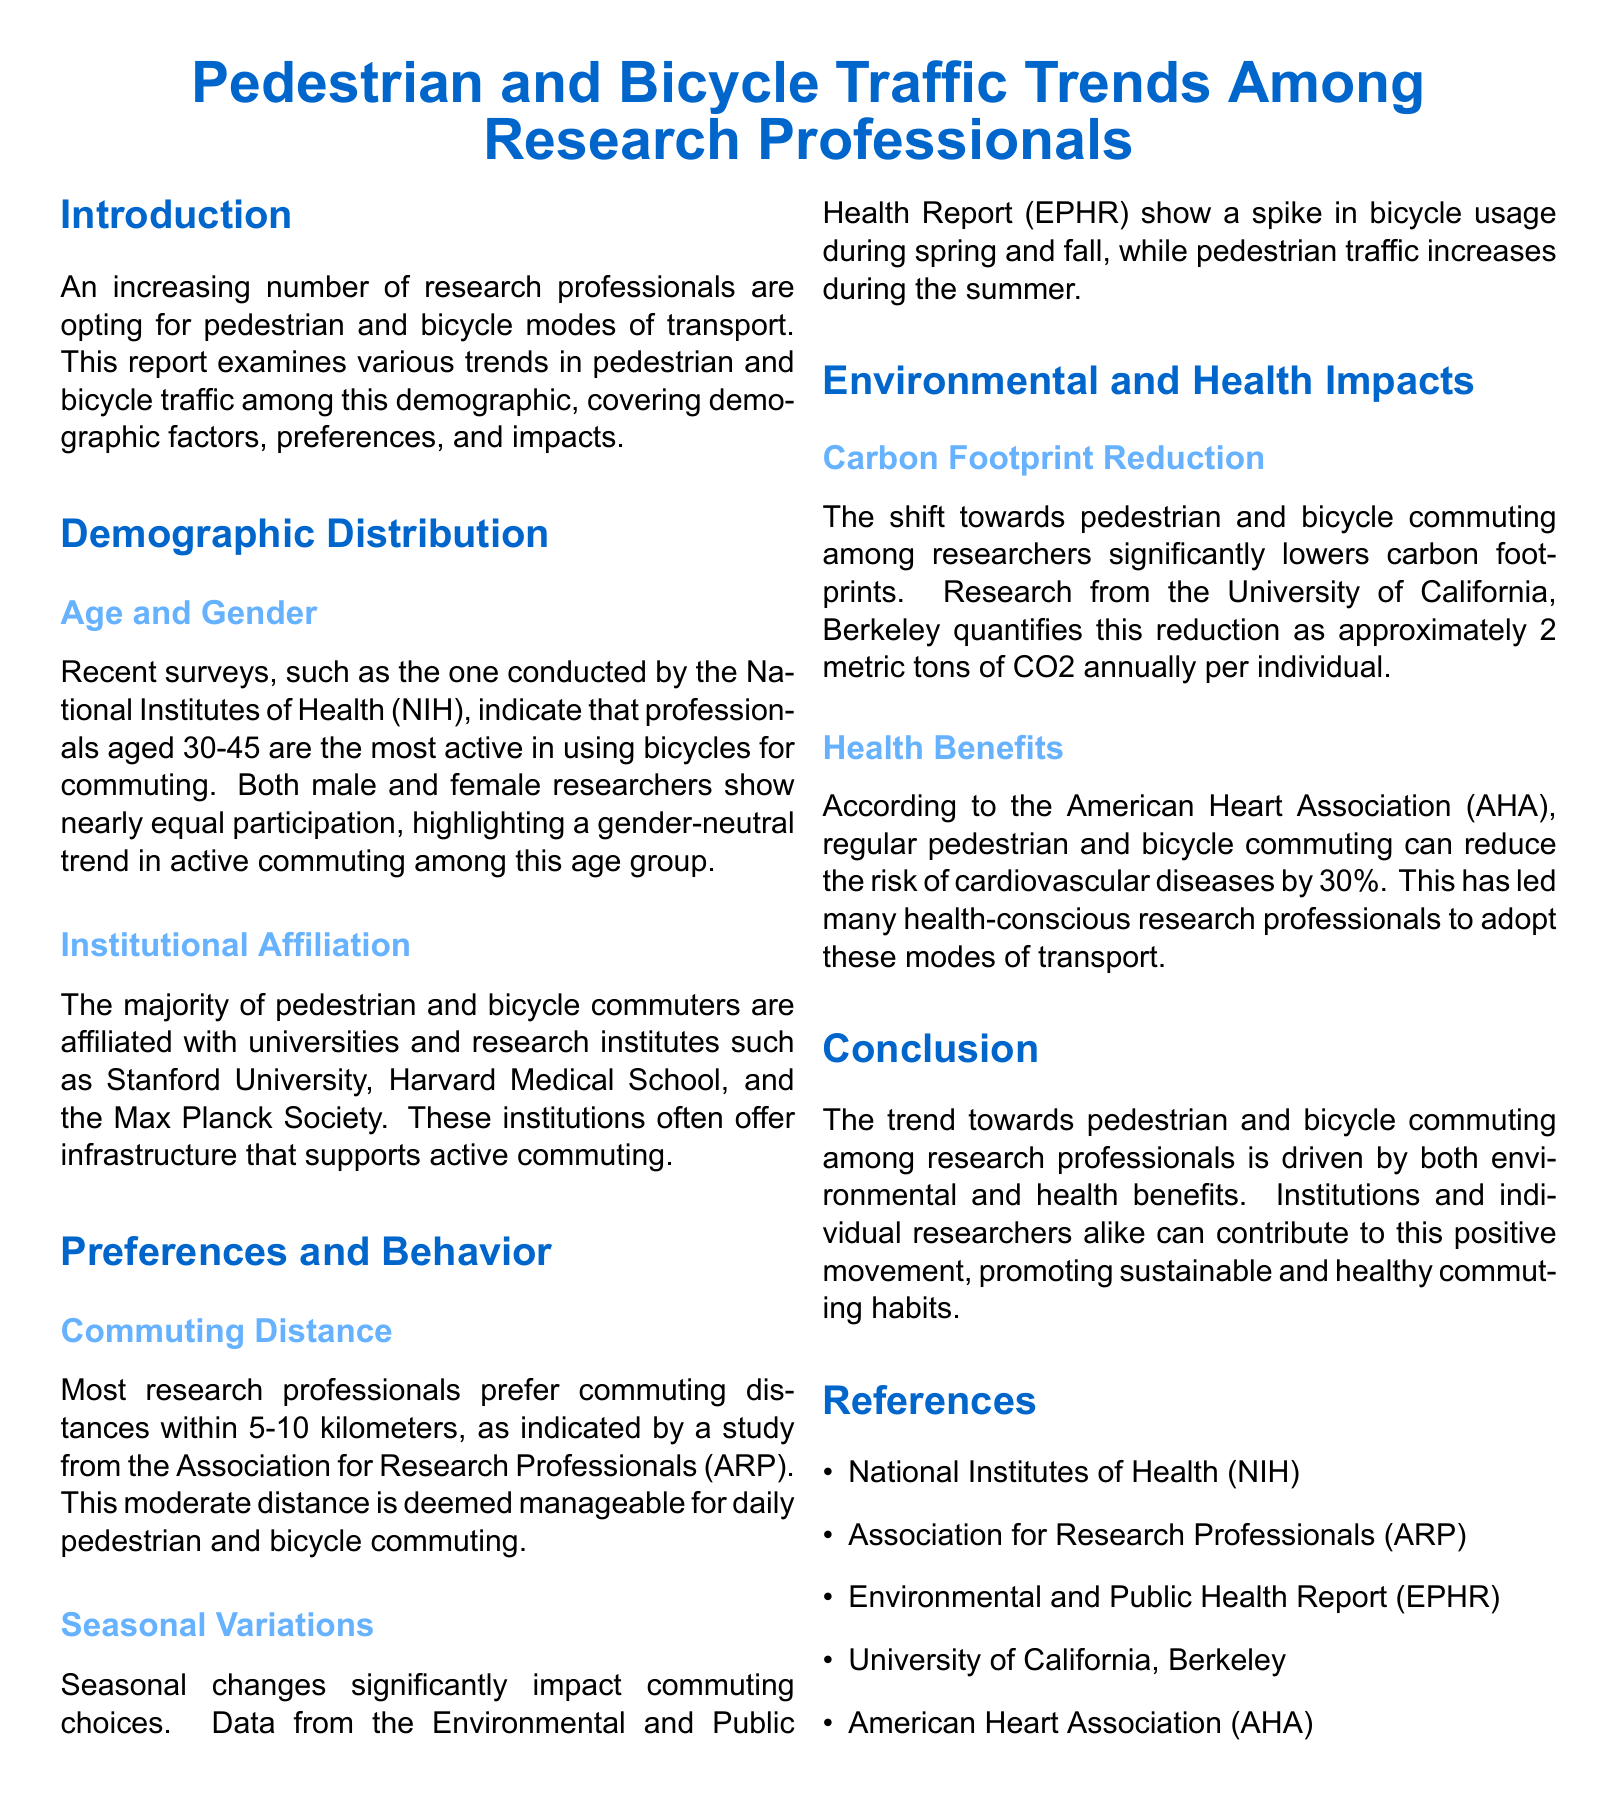What age group is most active in bicycle commuting? The document states that professionals aged 30-45 are the most active in using bicycles for commuting.
Answer: 30-45 Which institutions show the highest percentage of pedestrian and bicycle commuters? The report mentions universities and research institutes like Stanford University, Harvard Medical School, and the Max Planck Society.
Answer: Stanford University, Harvard Medical School, Max Planck Society What is the preferred commuting distance for most research professionals? According to the document, most research professionals prefer commuting distances within 5-10 kilometers.
Answer: 5-10 kilometers During which seasons does bicycle usage spike? The document indicates a spike in bicycle usage during spring and fall.
Answer: Spring and fall What is the estimated annual carbon footprint reduction per individual? The University of California, Berkeley quantifies the reduction as approximately 2 metric tons of CO2 annually per individual.
Answer: 2 metric tons By how much can regular commuting reduce the risk of cardiovascular diseases? The American Heart Association states that regular commuting can reduce the risk by 30%.
Answer: 30% What are the two main benefits driving the trend towards active commuting? The trend is driven by environmental and health benefits, as stated in the conclusion.
Answer: Environmental and health benefits What type of report is this document classified as? The structure and content indicate it is a traffic report focusing on pedestrian and bicycle traffic trends.
Answer: Traffic report 